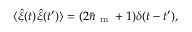Convert formula to latex. <formula><loc_0><loc_0><loc_500><loc_500>\langle \hat { \xi } ( t ) \hat { \xi } ( t ^ { \prime } ) \rangle = ( 2 \bar { n } _ { m } + 1 ) \delta ( t - t ^ { \prime } ) ,</formula> 